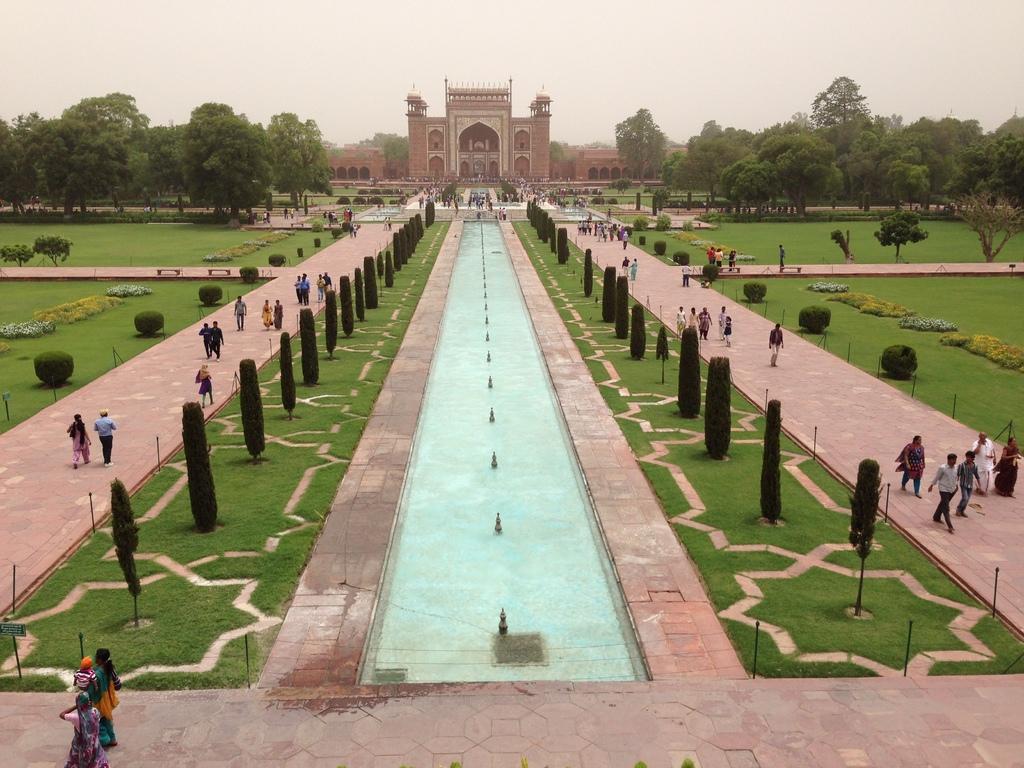How would you summarize this image in a sentence or two? In this picture we can see Taj Mahal garden, there are some people walking here, we can see grass, trees and some bushes here, there is water, we can see sky at the top of the picture. 